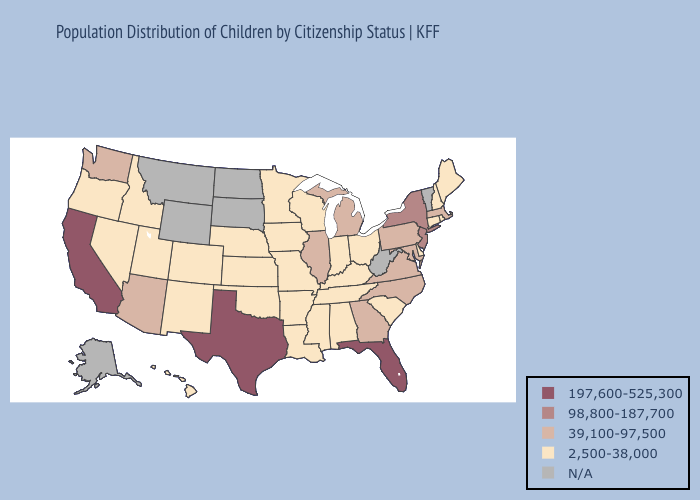Does the map have missing data?
Keep it brief. Yes. What is the value of Wyoming?
Answer briefly. N/A. Name the states that have a value in the range N/A?
Quick response, please. Alaska, Montana, North Dakota, South Dakota, Vermont, West Virginia, Wyoming. What is the value of Washington?
Keep it brief. 39,100-97,500. Does Iowa have the lowest value in the USA?
Concise answer only. Yes. Name the states that have a value in the range N/A?
Quick response, please. Alaska, Montana, North Dakota, South Dakota, Vermont, West Virginia, Wyoming. What is the lowest value in states that border Nevada?
Keep it brief. 2,500-38,000. Name the states that have a value in the range N/A?
Give a very brief answer. Alaska, Montana, North Dakota, South Dakota, Vermont, West Virginia, Wyoming. What is the value of Wyoming?
Be succinct. N/A. Name the states that have a value in the range 197,600-525,300?
Be succinct. California, Florida, Texas. Which states have the lowest value in the USA?
Answer briefly. Alabama, Arkansas, Colorado, Connecticut, Delaware, Hawaii, Idaho, Indiana, Iowa, Kansas, Kentucky, Louisiana, Maine, Minnesota, Mississippi, Missouri, Nebraska, Nevada, New Hampshire, New Mexico, Ohio, Oklahoma, Oregon, Rhode Island, South Carolina, Tennessee, Utah, Wisconsin. Name the states that have a value in the range 197,600-525,300?
Answer briefly. California, Florida, Texas. What is the lowest value in the West?
Write a very short answer. 2,500-38,000. 